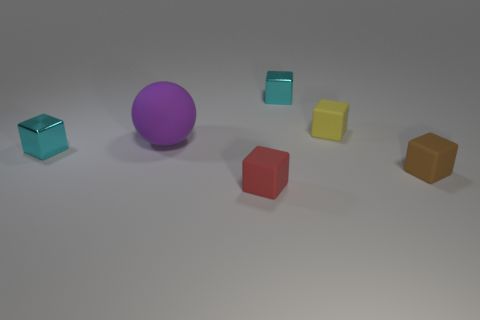Subtract all red cubes. How many cubes are left? 4 Subtract all red rubber blocks. How many blocks are left? 4 Subtract all gray cubes. Subtract all purple cylinders. How many cubes are left? 5 Add 2 yellow objects. How many objects exist? 8 Subtract all spheres. How many objects are left? 5 Subtract 0 gray cylinders. How many objects are left? 6 Subtract all small blue metallic cylinders. Subtract all big purple matte objects. How many objects are left? 5 Add 2 tiny yellow blocks. How many tiny yellow blocks are left? 3 Add 3 matte spheres. How many matte spheres exist? 4 